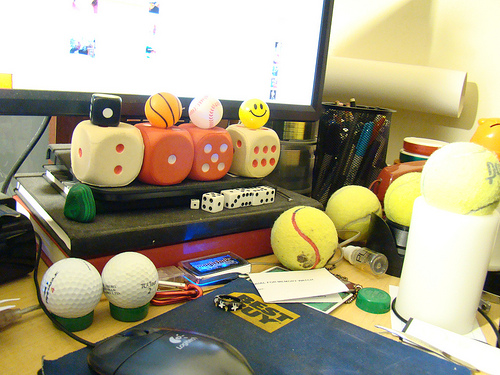<image>
Is the dice on the desk? No. The dice is not positioned on the desk. They may be near each other, but the dice is not supported by or resting on top of the desk. Is the ball in front of the computer screen? Yes. The ball is positioned in front of the computer screen, appearing closer to the camera viewpoint. Is the smiley face above the dice? Yes. The smiley face is positioned above the dice in the vertical space, higher up in the scene. 